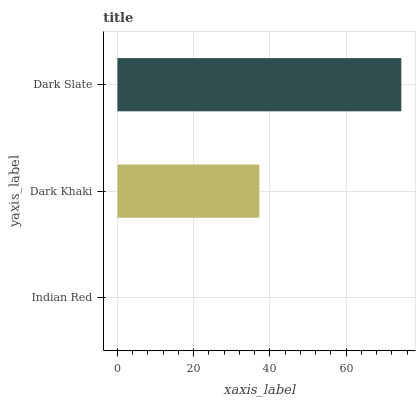Is Indian Red the minimum?
Answer yes or no. Yes. Is Dark Slate the maximum?
Answer yes or no. Yes. Is Dark Khaki the minimum?
Answer yes or no. No. Is Dark Khaki the maximum?
Answer yes or no. No. Is Dark Khaki greater than Indian Red?
Answer yes or no. Yes. Is Indian Red less than Dark Khaki?
Answer yes or no. Yes. Is Indian Red greater than Dark Khaki?
Answer yes or no. No. Is Dark Khaki less than Indian Red?
Answer yes or no. No. Is Dark Khaki the high median?
Answer yes or no. Yes. Is Dark Khaki the low median?
Answer yes or no. Yes. Is Dark Slate the high median?
Answer yes or no. No. Is Indian Red the low median?
Answer yes or no. No. 